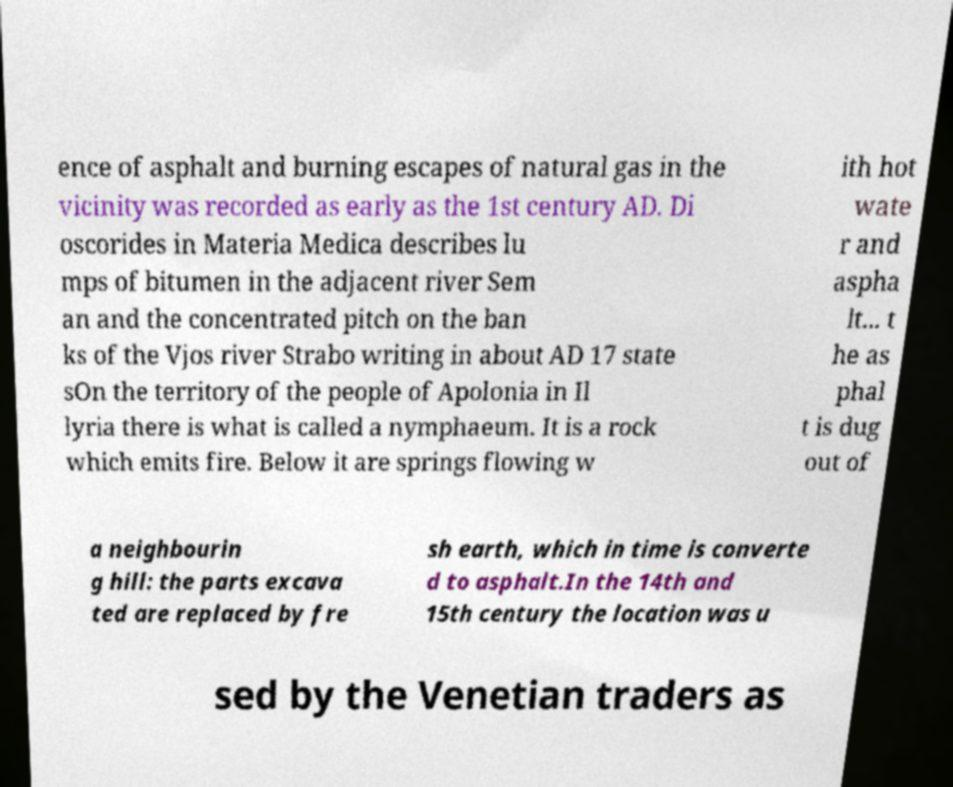Could you extract and type out the text from this image? ence of asphalt and burning escapes of natural gas in the vicinity was recorded as early as the 1st century AD. Di oscorides in Materia Medica describes lu mps of bitumen in the adjacent river Sem an and the concentrated pitch on the ban ks of the Vjos river Strabo writing in about AD 17 state sOn the territory of the people of Apolonia in Il lyria there is what is called a nymphaeum. It is a rock which emits fire. Below it are springs flowing w ith hot wate r and aspha lt... t he as phal t is dug out of a neighbourin g hill: the parts excava ted are replaced by fre sh earth, which in time is converte d to asphalt.In the 14th and 15th century the location was u sed by the Venetian traders as 